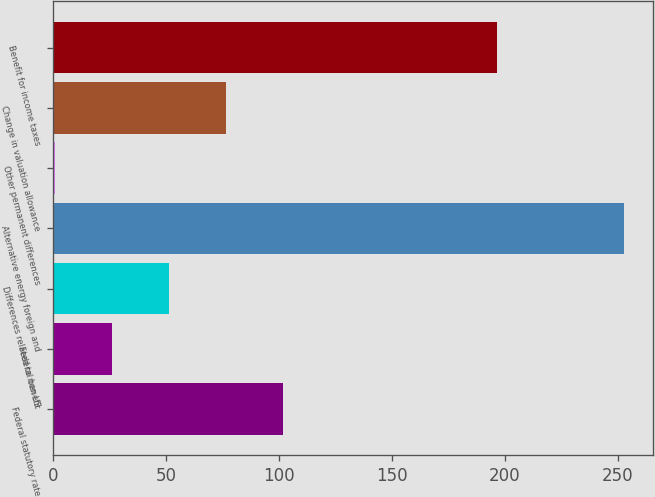<chart> <loc_0><loc_0><loc_500><loc_500><bar_chart><fcel>Federal statutory rate<fcel>Federal benefit<fcel>Differences related to non US<fcel>Alternative energy foreign and<fcel>Other permanent differences<fcel>Change in valuation allowance<fcel>Benefit for income taxes<nl><fcel>101.7<fcel>26.1<fcel>51.3<fcel>252.9<fcel>0.9<fcel>76.5<fcel>196.5<nl></chart> 